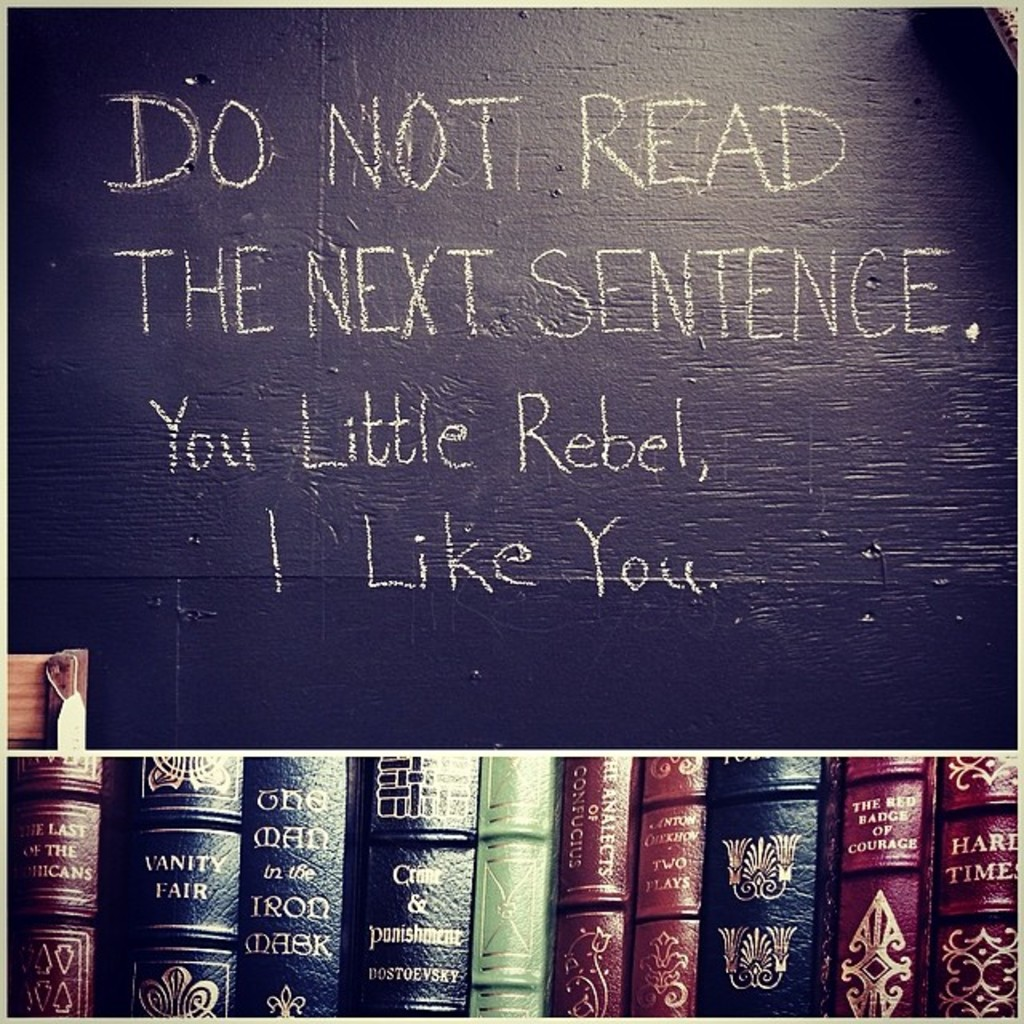What do you see happening in this image? The image captures a charming and humorous scene where a blackboard is humorously inscribed with the message 'Do not read the next sentence. You little rebel, I like you.' This playful interaction not only draws in the viewer but also subtly compliments them for their curiosity. Below the blackboard, a shelf is laden with a variety of classic books, showcasing intricate spines and titles like 'Vanity Fair' and 'The Count of Monte Cristo.' This arrangement hints at a cozy, intellectual environment, likely a corner designed to stimulate reading and provoke thought, combining a sense of rebellion with intellectual engagement. 